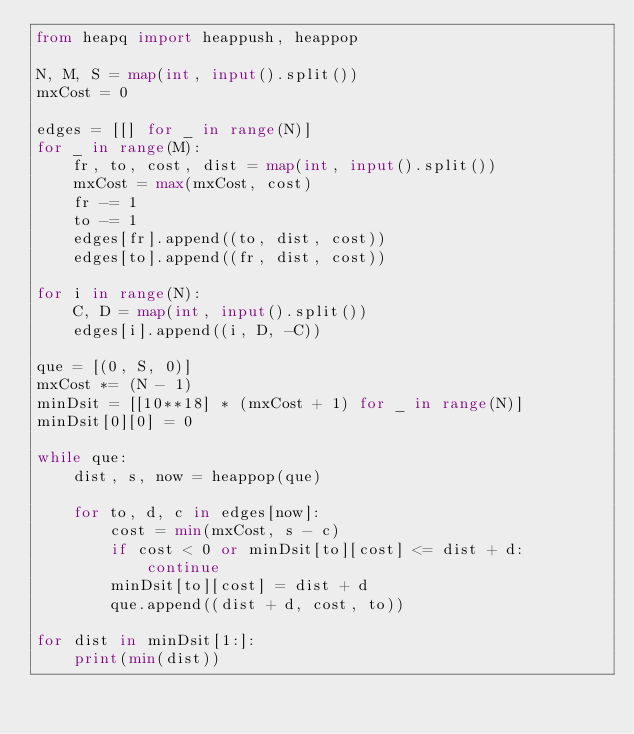<code> <loc_0><loc_0><loc_500><loc_500><_Python_>from heapq import heappush, heappop

N, M, S = map(int, input().split())
mxCost = 0

edges = [[] for _ in range(N)]
for _ in range(M):
    fr, to, cost, dist = map(int, input().split())
    mxCost = max(mxCost, cost)
    fr -= 1
    to -= 1
    edges[fr].append((to, dist, cost))
    edges[to].append((fr, dist, cost))

for i in range(N):
    C, D = map(int, input().split())
    edges[i].append((i, D, -C))

que = [(0, S, 0)]
mxCost *= (N - 1)
minDsit = [[10**18] * (mxCost + 1) for _ in range(N)]
minDsit[0][0] = 0

while que:
    dist, s, now = heappop(que)

    for to, d, c in edges[now]:
        cost = min(mxCost, s - c)
        if cost < 0 or minDsit[to][cost] <= dist + d:
            continue
        minDsit[to][cost] = dist + d
        que.append((dist + d, cost, to))

for dist in minDsit[1:]:
    print(min(dist))
</code> 